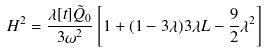Convert formula to latex. <formula><loc_0><loc_0><loc_500><loc_500>H ^ { 2 } = \frac { \lambda [ t ] \tilde { Q } _ { 0 } } { 3 \omega ^ { 2 } } \left [ 1 + ( 1 - 3 \lambda ) 3 \lambda L - \frac { 9 } { 2 } \lambda ^ { 2 } \right ]</formula> 